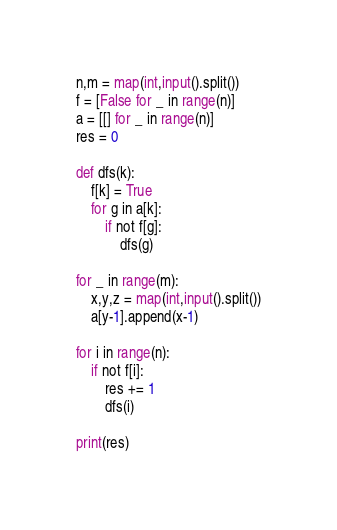<code> <loc_0><loc_0><loc_500><loc_500><_Python_>n,m = map(int,input().split())
f = [False for _ in range(n)]
a = [[] for _ in range(n)]
res = 0

def dfs(k):
    f[k] = True
    for g in a[k]:
        if not f[g]:
            dfs(g)

for _ in range(m):
    x,y,z = map(int,input().split())
    a[y-1].append(x-1)

for i in range(n):
    if not f[i]:
        res += 1
        dfs(i)

print(res)</code> 